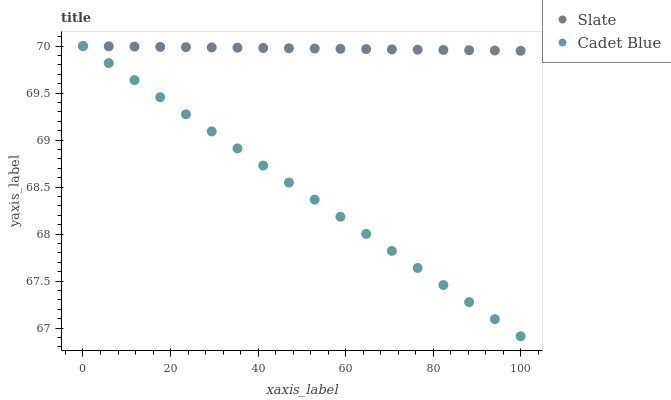Does Cadet Blue have the minimum area under the curve?
Answer yes or no. Yes. Does Slate have the maximum area under the curve?
Answer yes or no. Yes. Does Cadet Blue have the maximum area under the curve?
Answer yes or no. No. Is Cadet Blue the smoothest?
Answer yes or no. Yes. Is Slate the roughest?
Answer yes or no. Yes. Is Cadet Blue the roughest?
Answer yes or no. No. Does Cadet Blue have the lowest value?
Answer yes or no. Yes. Does Cadet Blue have the highest value?
Answer yes or no. Yes. Does Cadet Blue intersect Slate?
Answer yes or no. Yes. Is Cadet Blue less than Slate?
Answer yes or no. No. Is Cadet Blue greater than Slate?
Answer yes or no. No. 